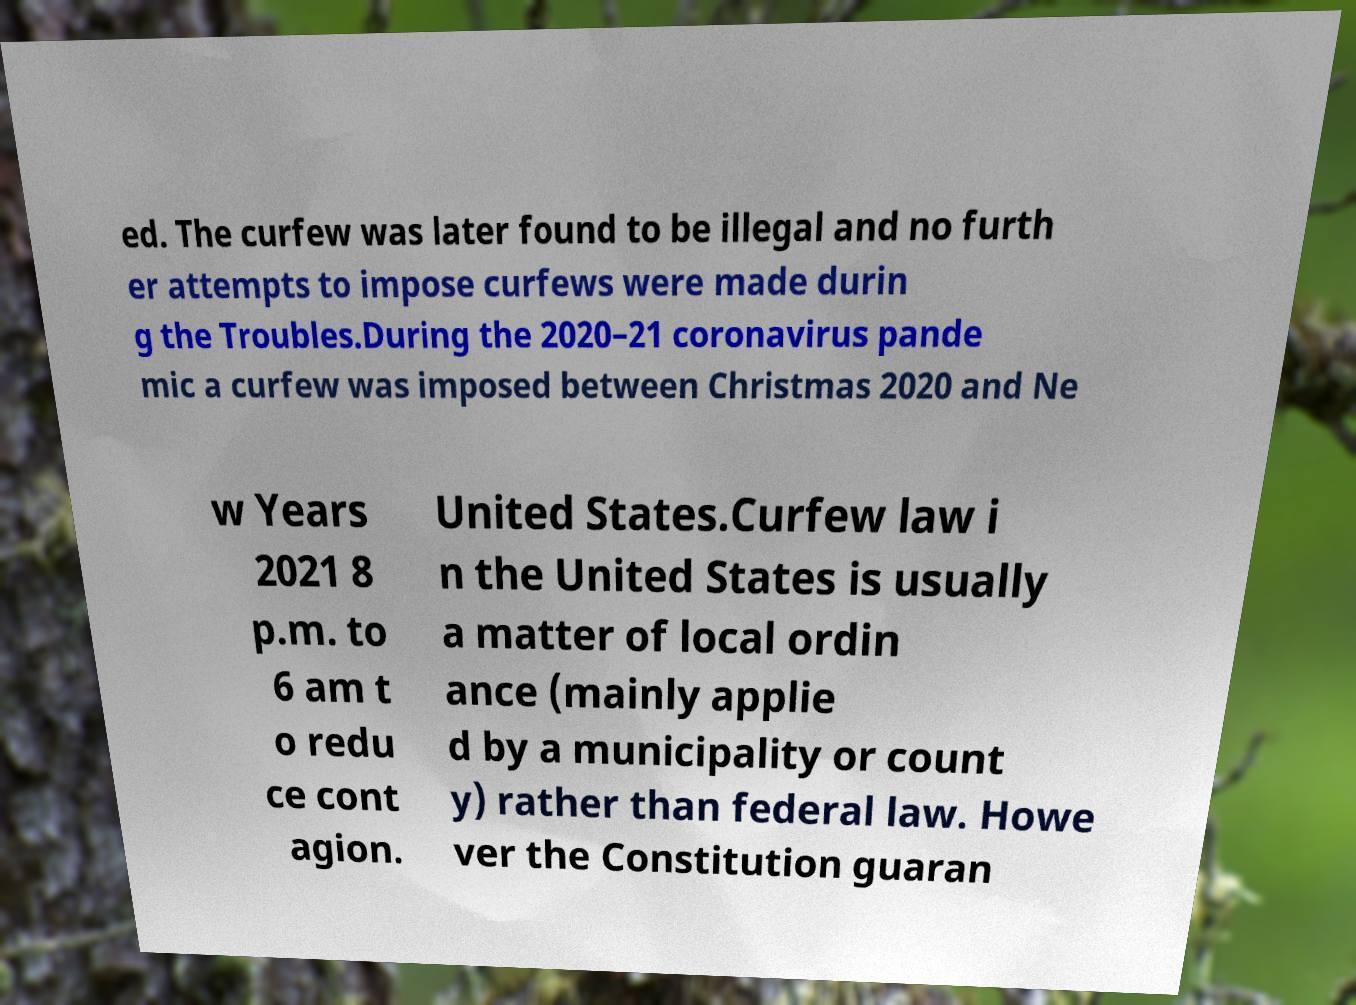Could you extract and type out the text from this image? ed. The curfew was later found to be illegal and no furth er attempts to impose curfews were made durin g the Troubles.During the 2020–21 coronavirus pande mic a curfew was imposed between Christmas 2020 and Ne w Years 2021 8 p.m. to 6 am t o redu ce cont agion. United States.Curfew law i n the United States is usually a matter of local ordin ance (mainly applie d by a municipality or count y) rather than federal law. Howe ver the Constitution guaran 